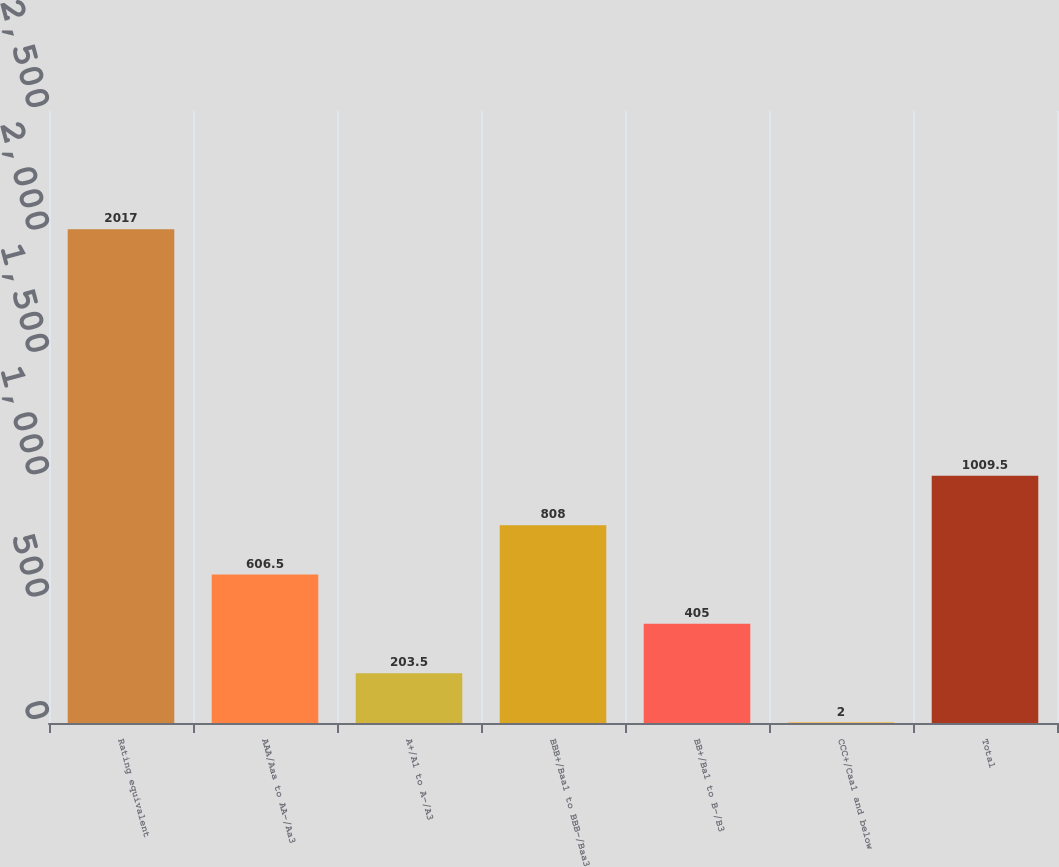<chart> <loc_0><loc_0><loc_500><loc_500><bar_chart><fcel>Rating equivalent<fcel>AAA/Aaa to AA-/Aa3<fcel>A+/A1 to A-/A3<fcel>BBB+/Baa1 to BBB-/Baa3<fcel>BB+/Ba1 to B-/B3<fcel>CCC+/Caa1 and below<fcel>Total<nl><fcel>2017<fcel>606.5<fcel>203.5<fcel>808<fcel>405<fcel>2<fcel>1009.5<nl></chart> 